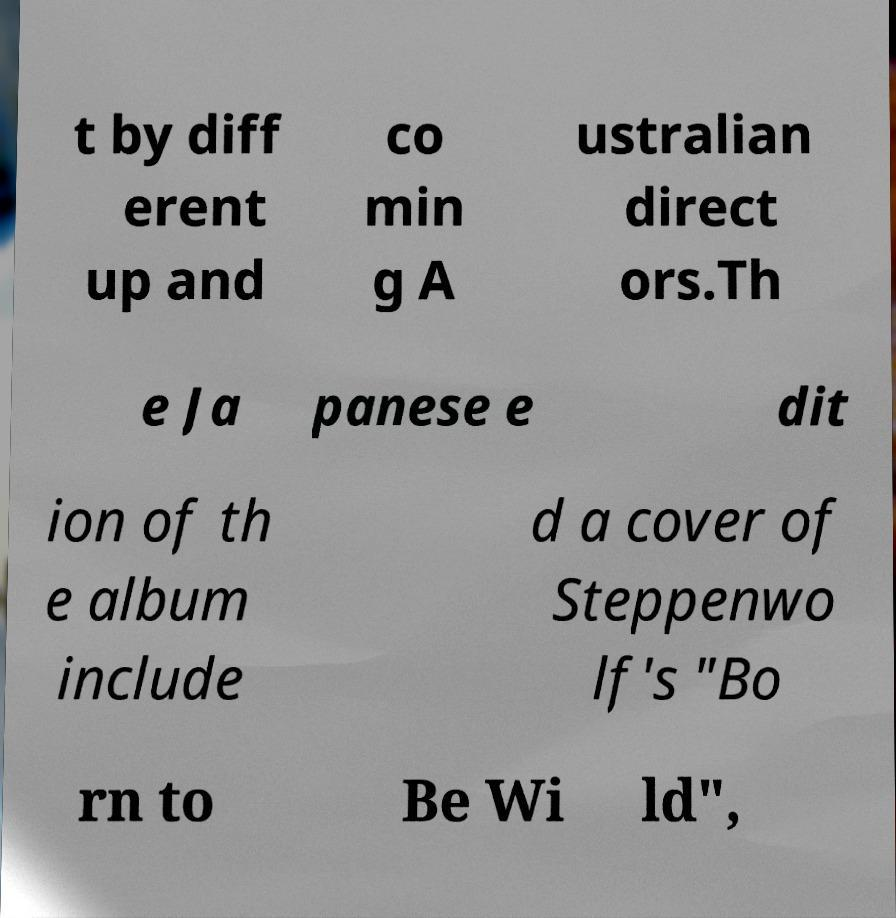What messages or text are displayed in this image? I need them in a readable, typed format. t by diff erent up and co min g A ustralian direct ors.Th e Ja panese e dit ion of th e album include d a cover of Steppenwo lf's "Bo rn to Be Wi ld", 